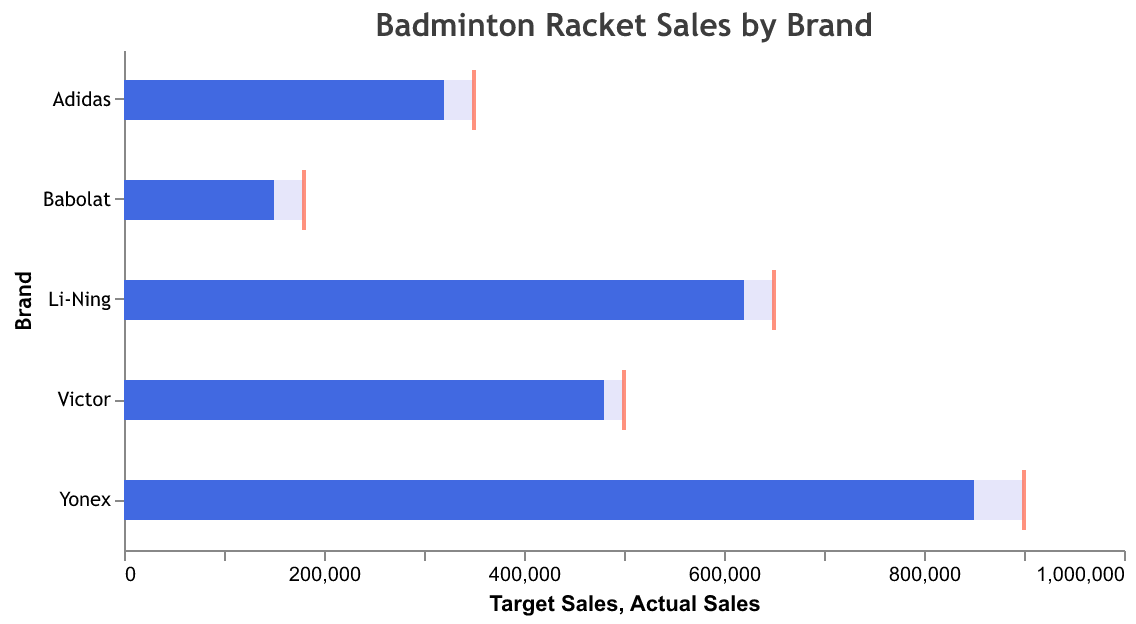What's the title of the figure? The title is usually at the top of the figure and provides a summary of what the chart is showing. The title here reads "Badminton Racket Sales by Brand".
Answer: Badminton Racket Sales by Brand How many brands are displayed in the chart? You can count the number of distinct brands listed on the y-axis. There are 5 unique brands shown: Yonex, Li-Ning, Victor, Adidas, and Babolat.
Answer: 5 Which brand had the highest actual sales? Look for the bar (in dark blue) that extends the farthest to the right. Yonex has the highest actual sales with 850,000 units sold.
Answer: Yonex What's the target sales for Adidas? Locate Adidas on the y-axis and then identify the corresponding tick mark (in red) on the x-axis. The target sales for Adidas are 350,000 units.
Answer: 350,000 Did Babolat meet its target sales? Compare the length of Babolat's actual sales bar to its target sales tick mark. Babolat's actual sales (150,000) fall short of its target (180,000).
Answer: No How much did Victor's actual sales fall short of the target? Subtract Victor's actual sales from its target sales: 500,000 - 480,000 = 20,000.
Answer: 20,000 Which brands use Graphite as the frame material? Check the data section or inspect the graph for brands mentioning Graphite in the frame material type. Yonex and Adidas use Graphite.
Answer: Yonex, Adidas What's the relation between actual sales and frame material for the top-selling brand? Find the top-selling brand, Yonex, and identify the frame material. Yonex, with the highest actual sales, uses Graphite as the frame material, indicating a possible preference or performance advantage.
Answer: Yonex uses Graphite Which brand has the lowest market share, and what is it? Check the market share data within the figure. Babolat has the lowest market share at 6%.
Answer: Babolat, 6% How much more is Yonex's actual sales compared to Li-Ning's? Subtract Li-Ning’s actual sales from Yonex's actual sales: 850,000 - 620,000 = 230,000.
Answer: 230,000 